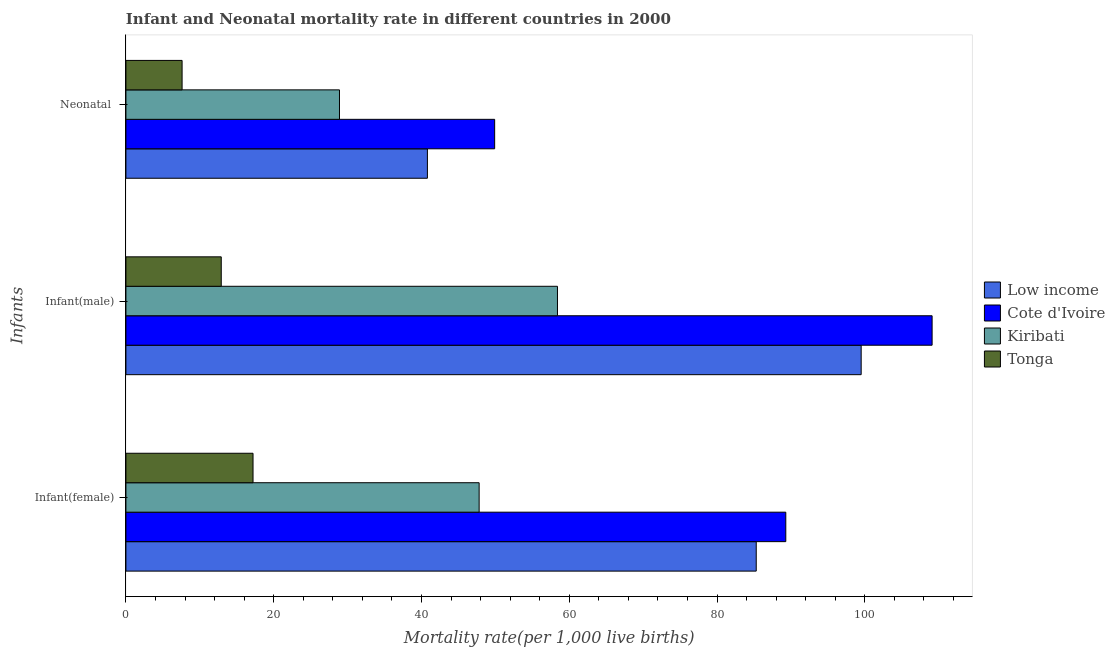How many different coloured bars are there?
Your response must be concise. 4. Are the number of bars on each tick of the Y-axis equal?
Your response must be concise. Yes. How many bars are there on the 1st tick from the bottom?
Keep it short and to the point. 4. What is the label of the 1st group of bars from the top?
Your answer should be very brief. Neonatal . What is the infant mortality rate(female) in Cote d'Ivoire?
Provide a short and direct response. 89.3. Across all countries, what is the maximum neonatal mortality rate?
Your answer should be compact. 49.9. Across all countries, what is the minimum infant mortality rate(male)?
Provide a succinct answer. 12.9. In which country was the infant mortality rate(female) maximum?
Your answer should be compact. Cote d'Ivoire. In which country was the infant mortality rate(female) minimum?
Give a very brief answer. Tonga. What is the total neonatal mortality rate in the graph?
Ensure brevity in your answer.  127.2. What is the difference between the infant mortality rate(male) in Tonga and that in Low income?
Offer a terse response. -86.6. What is the difference between the neonatal mortality rate in Cote d'Ivoire and the infant mortality rate(female) in Low income?
Provide a short and direct response. -35.4. What is the average infant mortality rate(male) per country?
Offer a very short reply. 69.97. What is the difference between the infant mortality rate(female) and neonatal mortality rate in Cote d'Ivoire?
Make the answer very short. 39.4. In how many countries, is the neonatal mortality rate greater than 92 ?
Keep it short and to the point. 0. What is the ratio of the infant mortality rate(male) in Low income to that in Tonga?
Provide a succinct answer. 7.71. Is the infant mortality rate(female) in Cote d'Ivoire less than that in Kiribati?
Provide a short and direct response. No. What is the difference between the highest and the second highest infant mortality rate(male)?
Give a very brief answer. 9.6. What is the difference between the highest and the lowest infant mortality rate(male)?
Offer a terse response. 96.2. What does the 3rd bar from the top in Infant(male) represents?
Offer a terse response. Cote d'Ivoire. What does the 3rd bar from the bottom in Infant(female) represents?
Offer a terse response. Kiribati. How many bars are there?
Your response must be concise. 12. How many countries are there in the graph?
Provide a short and direct response. 4. Are the values on the major ticks of X-axis written in scientific E-notation?
Your response must be concise. No. Does the graph contain grids?
Offer a terse response. No. Where does the legend appear in the graph?
Your answer should be compact. Center right. How many legend labels are there?
Provide a short and direct response. 4. How are the legend labels stacked?
Ensure brevity in your answer.  Vertical. What is the title of the graph?
Ensure brevity in your answer.  Infant and Neonatal mortality rate in different countries in 2000. What is the label or title of the X-axis?
Ensure brevity in your answer.  Mortality rate(per 1,0 live births). What is the label or title of the Y-axis?
Your answer should be compact. Infants. What is the Mortality rate(per 1,000 live births) in Low income in Infant(female)?
Offer a very short reply. 85.3. What is the Mortality rate(per 1,000 live births) of Cote d'Ivoire in Infant(female)?
Give a very brief answer. 89.3. What is the Mortality rate(per 1,000 live births) in Kiribati in Infant(female)?
Make the answer very short. 47.8. What is the Mortality rate(per 1,000 live births) of Low income in Infant(male)?
Your response must be concise. 99.5. What is the Mortality rate(per 1,000 live births) of Cote d'Ivoire in Infant(male)?
Your answer should be compact. 109.1. What is the Mortality rate(per 1,000 live births) of Kiribati in Infant(male)?
Ensure brevity in your answer.  58.4. What is the Mortality rate(per 1,000 live births) in Tonga in Infant(male)?
Your response must be concise. 12.9. What is the Mortality rate(per 1,000 live births) of Low income in Neonatal ?
Ensure brevity in your answer.  40.8. What is the Mortality rate(per 1,000 live births) of Cote d'Ivoire in Neonatal ?
Make the answer very short. 49.9. What is the Mortality rate(per 1,000 live births) of Kiribati in Neonatal ?
Provide a succinct answer. 28.9. What is the Mortality rate(per 1,000 live births) of Tonga in Neonatal ?
Give a very brief answer. 7.6. Across all Infants, what is the maximum Mortality rate(per 1,000 live births) in Low income?
Your answer should be compact. 99.5. Across all Infants, what is the maximum Mortality rate(per 1,000 live births) of Cote d'Ivoire?
Your response must be concise. 109.1. Across all Infants, what is the maximum Mortality rate(per 1,000 live births) of Kiribati?
Your answer should be very brief. 58.4. Across all Infants, what is the minimum Mortality rate(per 1,000 live births) of Low income?
Make the answer very short. 40.8. Across all Infants, what is the minimum Mortality rate(per 1,000 live births) of Cote d'Ivoire?
Keep it short and to the point. 49.9. Across all Infants, what is the minimum Mortality rate(per 1,000 live births) in Kiribati?
Your answer should be compact. 28.9. Across all Infants, what is the minimum Mortality rate(per 1,000 live births) of Tonga?
Your answer should be compact. 7.6. What is the total Mortality rate(per 1,000 live births) of Low income in the graph?
Your answer should be compact. 225.6. What is the total Mortality rate(per 1,000 live births) of Cote d'Ivoire in the graph?
Offer a terse response. 248.3. What is the total Mortality rate(per 1,000 live births) in Kiribati in the graph?
Make the answer very short. 135.1. What is the total Mortality rate(per 1,000 live births) in Tonga in the graph?
Your answer should be very brief. 37.7. What is the difference between the Mortality rate(per 1,000 live births) of Low income in Infant(female) and that in Infant(male)?
Your answer should be very brief. -14.2. What is the difference between the Mortality rate(per 1,000 live births) in Cote d'Ivoire in Infant(female) and that in Infant(male)?
Ensure brevity in your answer.  -19.8. What is the difference between the Mortality rate(per 1,000 live births) of Tonga in Infant(female) and that in Infant(male)?
Provide a succinct answer. 4.3. What is the difference between the Mortality rate(per 1,000 live births) of Low income in Infant(female) and that in Neonatal ?
Provide a short and direct response. 44.5. What is the difference between the Mortality rate(per 1,000 live births) of Cote d'Ivoire in Infant(female) and that in Neonatal ?
Your answer should be compact. 39.4. What is the difference between the Mortality rate(per 1,000 live births) in Kiribati in Infant(female) and that in Neonatal ?
Offer a terse response. 18.9. What is the difference between the Mortality rate(per 1,000 live births) of Tonga in Infant(female) and that in Neonatal ?
Ensure brevity in your answer.  9.6. What is the difference between the Mortality rate(per 1,000 live births) in Low income in Infant(male) and that in Neonatal ?
Offer a very short reply. 58.7. What is the difference between the Mortality rate(per 1,000 live births) of Cote d'Ivoire in Infant(male) and that in Neonatal ?
Offer a very short reply. 59.2. What is the difference between the Mortality rate(per 1,000 live births) of Kiribati in Infant(male) and that in Neonatal ?
Your response must be concise. 29.5. What is the difference between the Mortality rate(per 1,000 live births) of Tonga in Infant(male) and that in Neonatal ?
Your answer should be compact. 5.3. What is the difference between the Mortality rate(per 1,000 live births) of Low income in Infant(female) and the Mortality rate(per 1,000 live births) of Cote d'Ivoire in Infant(male)?
Offer a terse response. -23.8. What is the difference between the Mortality rate(per 1,000 live births) in Low income in Infant(female) and the Mortality rate(per 1,000 live births) in Kiribati in Infant(male)?
Ensure brevity in your answer.  26.9. What is the difference between the Mortality rate(per 1,000 live births) in Low income in Infant(female) and the Mortality rate(per 1,000 live births) in Tonga in Infant(male)?
Offer a terse response. 72.4. What is the difference between the Mortality rate(per 1,000 live births) in Cote d'Ivoire in Infant(female) and the Mortality rate(per 1,000 live births) in Kiribati in Infant(male)?
Offer a very short reply. 30.9. What is the difference between the Mortality rate(per 1,000 live births) of Cote d'Ivoire in Infant(female) and the Mortality rate(per 1,000 live births) of Tonga in Infant(male)?
Offer a very short reply. 76.4. What is the difference between the Mortality rate(per 1,000 live births) in Kiribati in Infant(female) and the Mortality rate(per 1,000 live births) in Tonga in Infant(male)?
Provide a short and direct response. 34.9. What is the difference between the Mortality rate(per 1,000 live births) of Low income in Infant(female) and the Mortality rate(per 1,000 live births) of Cote d'Ivoire in Neonatal ?
Keep it short and to the point. 35.4. What is the difference between the Mortality rate(per 1,000 live births) of Low income in Infant(female) and the Mortality rate(per 1,000 live births) of Kiribati in Neonatal ?
Keep it short and to the point. 56.4. What is the difference between the Mortality rate(per 1,000 live births) in Low income in Infant(female) and the Mortality rate(per 1,000 live births) in Tonga in Neonatal ?
Offer a very short reply. 77.7. What is the difference between the Mortality rate(per 1,000 live births) in Cote d'Ivoire in Infant(female) and the Mortality rate(per 1,000 live births) in Kiribati in Neonatal ?
Make the answer very short. 60.4. What is the difference between the Mortality rate(per 1,000 live births) of Cote d'Ivoire in Infant(female) and the Mortality rate(per 1,000 live births) of Tonga in Neonatal ?
Give a very brief answer. 81.7. What is the difference between the Mortality rate(per 1,000 live births) of Kiribati in Infant(female) and the Mortality rate(per 1,000 live births) of Tonga in Neonatal ?
Give a very brief answer. 40.2. What is the difference between the Mortality rate(per 1,000 live births) in Low income in Infant(male) and the Mortality rate(per 1,000 live births) in Cote d'Ivoire in Neonatal ?
Give a very brief answer. 49.6. What is the difference between the Mortality rate(per 1,000 live births) of Low income in Infant(male) and the Mortality rate(per 1,000 live births) of Kiribati in Neonatal ?
Your answer should be compact. 70.6. What is the difference between the Mortality rate(per 1,000 live births) of Low income in Infant(male) and the Mortality rate(per 1,000 live births) of Tonga in Neonatal ?
Your answer should be very brief. 91.9. What is the difference between the Mortality rate(per 1,000 live births) in Cote d'Ivoire in Infant(male) and the Mortality rate(per 1,000 live births) in Kiribati in Neonatal ?
Offer a terse response. 80.2. What is the difference between the Mortality rate(per 1,000 live births) of Cote d'Ivoire in Infant(male) and the Mortality rate(per 1,000 live births) of Tonga in Neonatal ?
Offer a terse response. 101.5. What is the difference between the Mortality rate(per 1,000 live births) in Kiribati in Infant(male) and the Mortality rate(per 1,000 live births) in Tonga in Neonatal ?
Your answer should be compact. 50.8. What is the average Mortality rate(per 1,000 live births) of Low income per Infants?
Offer a terse response. 75.2. What is the average Mortality rate(per 1,000 live births) of Cote d'Ivoire per Infants?
Give a very brief answer. 82.77. What is the average Mortality rate(per 1,000 live births) in Kiribati per Infants?
Offer a very short reply. 45.03. What is the average Mortality rate(per 1,000 live births) of Tonga per Infants?
Provide a succinct answer. 12.57. What is the difference between the Mortality rate(per 1,000 live births) in Low income and Mortality rate(per 1,000 live births) in Cote d'Ivoire in Infant(female)?
Your answer should be very brief. -4. What is the difference between the Mortality rate(per 1,000 live births) in Low income and Mortality rate(per 1,000 live births) in Kiribati in Infant(female)?
Provide a succinct answer. 37.5. What is the difference between the Mortality rate(per 1,000 live births) in Low income and Mortality rate(per 1,000 live births) in Tonga in Infant(female)?
Your answer should be very brief. 68.1. What is the difference between the Mortality rate(per 1,000 live births) of Cote d'Ivoire and Mortality rate(per 1,000 live births) of Kiribati in Infant(female)?
Your response must be concise. 41.5. What is the difference between the Mortality rate(per 1,000 live births) of Cote d'Ivoire and Mortality rate(per 1,000 live births) of Tonga in Infant(female)?
Provide a succinct answer. 72.1. What is the difference between the Mortality rate(per 1,000 live births) in Kiribati and Mortality rate(per 1,000 live births) in Tonga in Infant(female)?
Your answer should be compact. 30.6. What is the difference between the Mortality rate(per 1,000 live births) of Low income and Mortality rate(per 1,000 live births) of Kiribati in Infant(male)?
Your answer should be very brief. 41.1. What is the difference between the Mortality rate(per 1,000 live births) of Low income and Mortality rate(per 1,000 live births) of Tonga in Infant(male)?
Your answer should be very brief. 86.6. What is the difference between the Mortality rate(per 1,000 live births) of Cote d'Ivoire and Mortality rate(per 1,000 live births) of Kiribati in Infant(male)?
Your answer should be very brief. 50.7. What is the difference between the Mortality rate(per 1,000 live births) in Cote d'Ivoire and Mortality rate(per 1,000 live births) in Tonga in Infant(male)?
Ensure brevity in your answer.  96.2. What is the difference between the Mortality rate(per 1,000 live births) in Kiribati and Mortality rate(per 1,000 live births) in Tonga in Infant(male)?
Offer a very short reply. 45.5. What is the difference between the Mortality rate(per 1,000 live births) of Low income and Mortality rate(per 1,000 live births) of Tonga in Neonatal ?
Ensure brevity in your answer.  33.2. What is the difference between the Mortality rate(per 1,000 live births) in Cote d'Ivoire and Mortality rate(per 1,000 live births) in Kiribati in Neonatal ?
Offer a very short reply. 21. What is the difference between the Mortality rate(per 1,000 live births) of Cote d'Ivoire and Mortality rate(per 1,000 live births) of Tonga in Neonatal ?
Keep it short and to the point. 42.3. What is the difference between the Mortality rate(per 1,000 live births) of Kiribati and Mortality rate(per 1,000 live births) of Tonga in Neonatal ?
Make the answer very short. 21.3. What is the ratio of the Mortality rate(per 1,000 live births) in Low income in Infant(female) to that in Infant(male)?
Your response must be concise. 0.86. What is the ratio of the Mortality rate(per 1,000 live births) in Cote d'Ivoire in Infant(female) to that in Infant(male)?
Your answer should be compact. 0.82. What is the ratio of the Mortality rate(per 1,000 live births) of Kiribati in Infant(female) to that in Infant(male)?
Offer a very short reply. 0.82. What is the ratio of the Mortality rate(per 1,000 live births) of Tonga in Infant(female) to that in Infant(male)?
Provide a succinct answer. 1.33. What is the ratio of the Mortality rate(per 1,000 live births) of Low income in Infant(female) to that in Neonatal ?
Keep it short and to the point. 2.09. What is the ratio of the Mortality rate(per 1,000 live births) in Cote d'Ivoire in Infant(female) to that in Neonatal ?
Your response must be concise. 1.79. What is the ratio of the Mortality rate(per 1,000 live births) of Kiribati in Infant(female) to that in Neonatal ?
Your answer should be compact. 1.65. What is the ratio of the Mortality rate(per 1,000 live births) in Tonga in Infant(female) to that in Neonatal ?
Offer a very short reply. 2.26. What is the ratio of the Mortality rate(per 1,000 live births) in Low income in Infant(male) to that in Neonatal ?
Ensure brevity in your answer.  2.44. What is the ratio of the Mortality rate(per 1,000 live births) of Cote d'Ivoire in Infant(male) to that in Neonatal ?
Provide a succinct answer. 2.19. What is the ratio of the Mortality rate(per 1,000 live births) in Kiribati in Infant(male) to that in Neonatal ?
Make the answer very short. 2.02. What is the ratio of the Mortality rate(per 1,000 live births) of Tonga in Infant(male) to that in Neonatal ?
Offer a terse response. 1.7. What is the difference between the highest and the second highest Mortality rate(per 1,000 live births) in Cote d'Ivoire?
Keep it short and to the point. 19.8. What is the difference between the highest and the second highest Mortality rate(per 1,000 live births) in Kiribati?
Offer a very short reply. 10.6. What is the difference between the highest and the second highest Mortality rate(per 1,000 live births) in Tonga?
Your response must be concise. 4.3. What is the difference between the highest and the lowest Mortality rate(per 1,000 live births) in Low income?
Keep it short and to the point. 58.7. What is the difference between the highest and the lowest Mortality rate(per 1,000 live births) in Cote d'Ivoire?
Offer a very short reply. 59.2. What is the difference between the highest and the lowest Mortality rate(per 1,000 live births) of Kiribati?
Your answer should be compact. 29.5. What is the difference between the highest and the lowest Mortality rate(per 1,000 live births) in Tonga?
Provide a succinct answer. 9.6. 